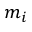Convert formula to latex. <formula><loc_0><loc_0><loc_500><loc_500>m _ { i }</formula> 